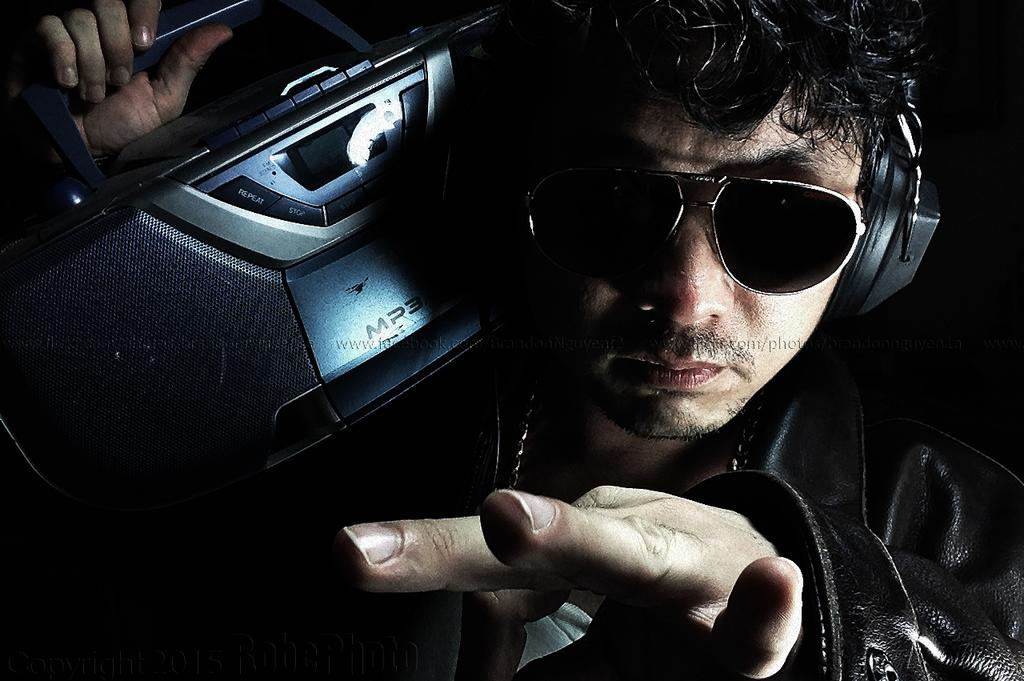Who is present in the image? There is a man in the image. What is the man wearing on his upper body? The man is wearing a black jacket. What protective gear is the man wearing? The man is wearing goggles. What device is the man wearing on his ears? The man is wearing headphones. What object is the man holding in his hand? The man is holding a tape recorder in his hand. How much wealth does the man in the image possess? The image does not provide any information about the man's wealth, so it cannot be determined. 